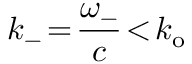Convert formula to latex. <formula><loc_0><loc_0><loc_500><loc_500>k _ { - } \, = \, \frac { \omega _ { - } } { c } \, < \, k _ { o }</formula> 